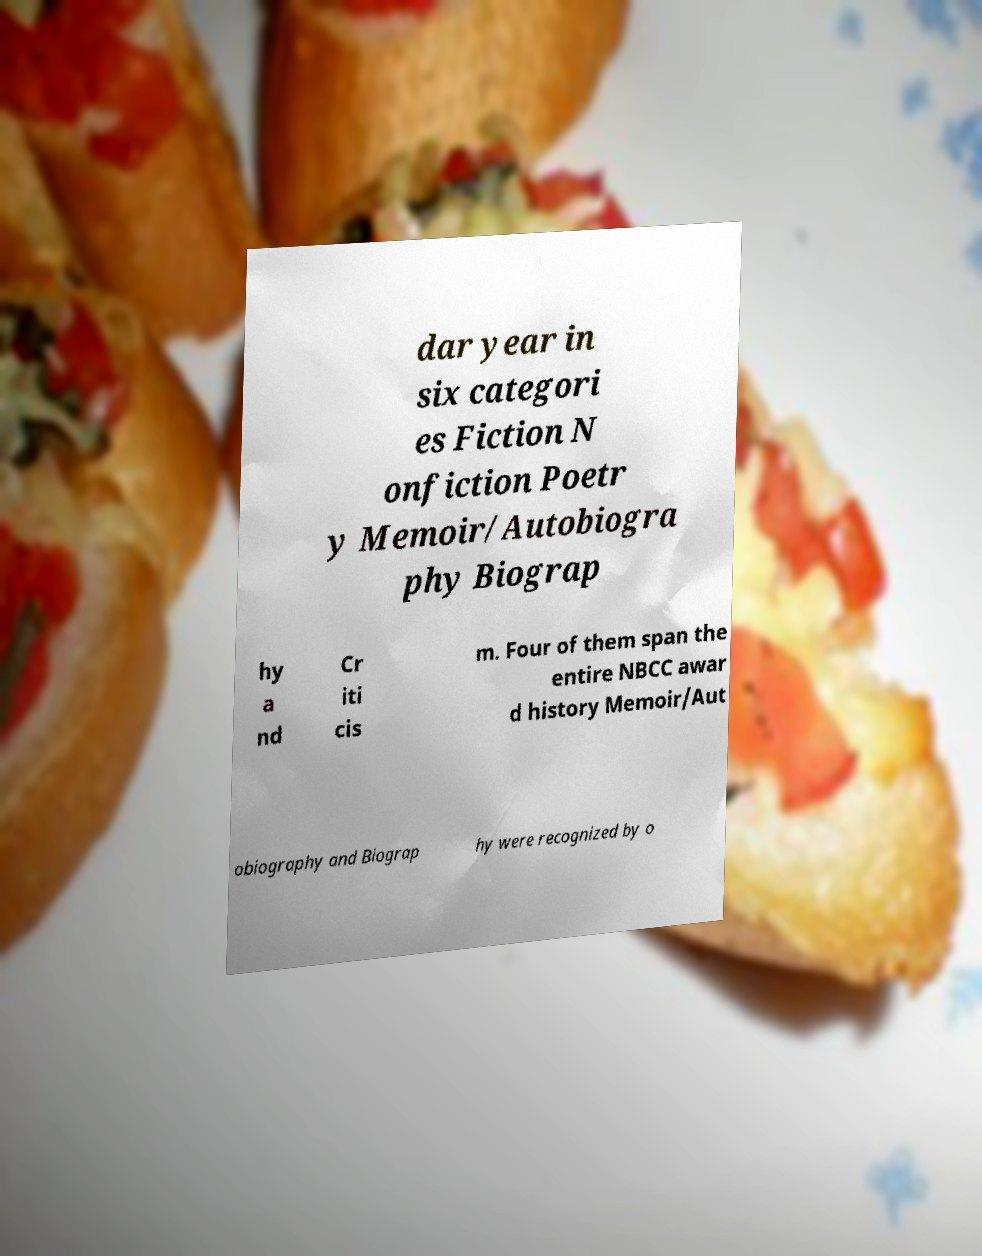Can you accurately transcribe the text from the provided image for me? dar year in six categori es Fiction N onfiction Poetr y Memoir/Autobiogra phy Biograp hy a nd Cr iti cis m. Four of them span the entire NBCC awar d history Memoir/Aut obiography and Biograp hy were recognized by o 